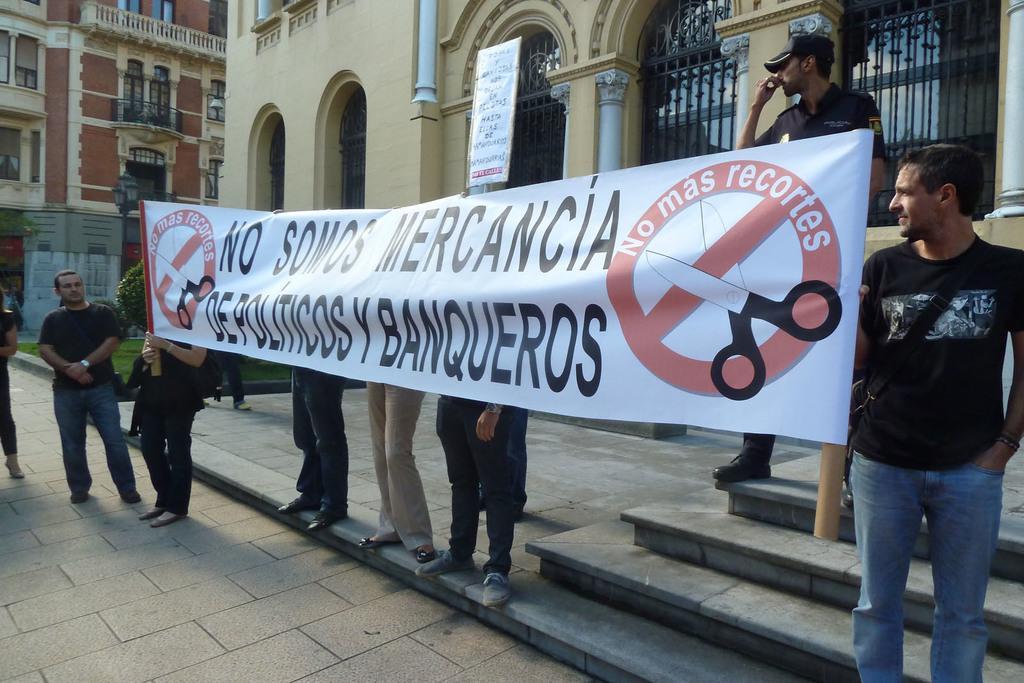Can you describe this image briefly? In this image there are few persons standing on the floor. Three persons are standing behind the banner. Two persons are holding the banner. Right side there is a person wearing a cap is standing on the stairs. Left side two persons are standing on the floor. Behind them there are few plants in the grassland. There is a street light. Background there are few buildings. Middle of the image there is a board. 